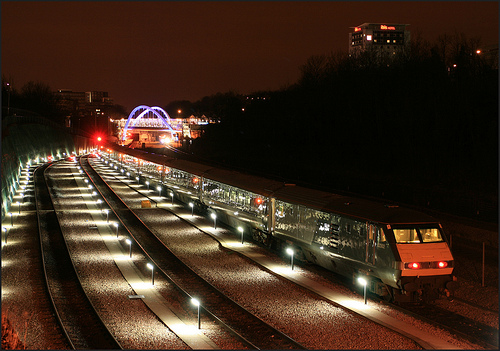Can you tell me something about the train in the picture? Certainly, the train has its interior lights on, revealing the rows of seats and the passengers inside. It is stationary, which might indicate it is at a platform awaiting departure or has just arrived. 